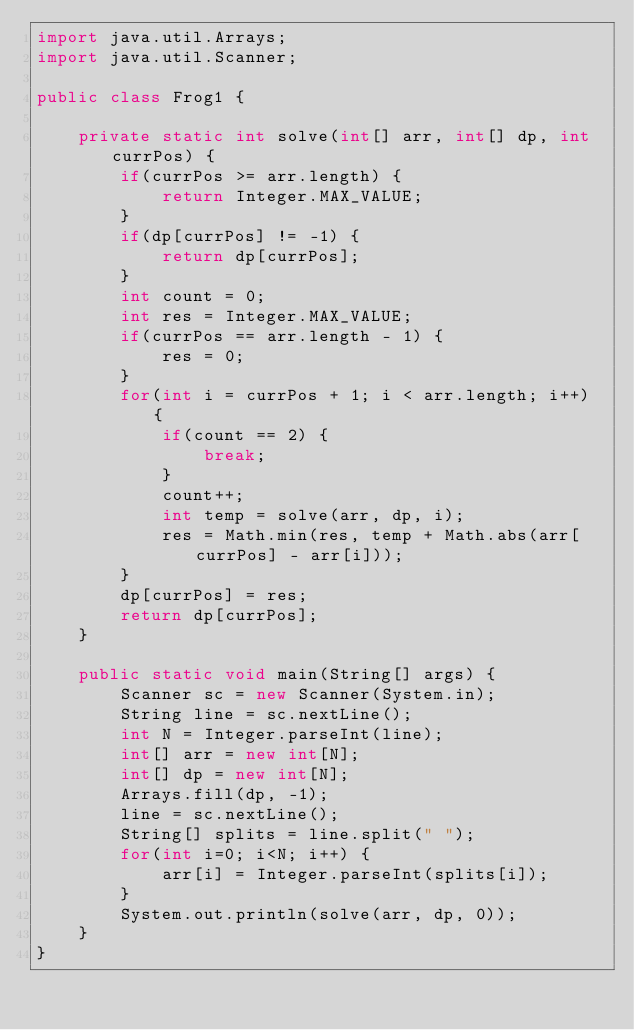Convert code to text. <code><loc_0><loc_0><loc_500><loc_500><_Java_>import java.util.Arrays;
import java.util.Scanner;

public class Frog1 {

    private static int solve(int[] arr, int[] dp, int currPos) {
        if(currPos >= arr.length) {
            return Integer.MAX_VALUE;
        }
        if(dp[currPos] != -1) {
            return dp[currPos];
        }
        int count = 0;
        int res = Integer.MAX_VALUE;
        if(currPos == arr.length - 1) {
            res = 0;
        }
        for(int i = currPos + 1; i < arr.length; i++) {
            if(count == 2) {
                break;
            }
            count++;
            int temp = solve(arr, dp, i);
            res = Math.min(res, temp + Math.abs(arr[currPos] - arr[i]));
        }
        dp[currPos] = res;
        return dp[currPos];
    }

    public static void main(String[] args) {
        Scanner sc = new Scanner(System.in);
        String line = sc.nextLine();
        int N = Integer.parseInt(line);
        int[] arr = new int[N];
        int[] dp = new int[N];
        Arrays.fill(dp, -1);
        line = sc.nextLine();
        String[] splits = line.split(" ");
        for(int i=0; i<N; i++) {
            arr[i] = Integer.parseInt(splits[i]);
        }
        System.out.println(solve(arr, dp, 0));
    }
}</code> 